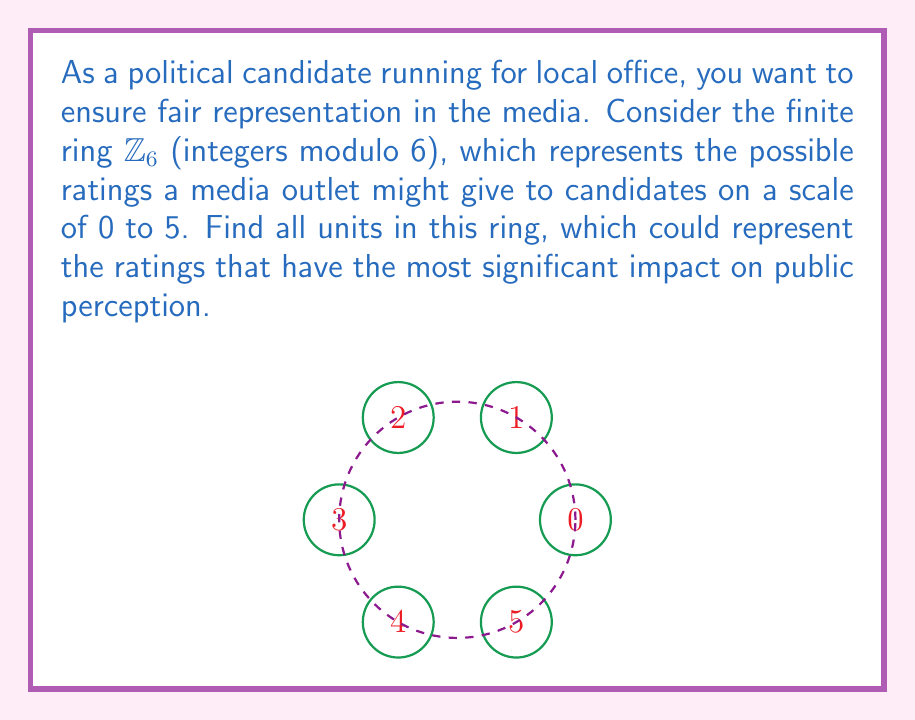What is the answer to this math problem? To find all units in the finite ring $\mathbb{Z}_6$, we need to identify elements that have multiplicative inverses. Let's approach this step-by-step:

1) In $\mathbb{Z}_6$, the elements are $\{0, 1, 2, 3, 4, 5\}$.

2) An element $a$ is a unit if there exists an element $b$ such that $ab \equiv 1 \pmod{6}$.

3) Let's check each element:

   For 0: $0 \cdot x \equiv 0 \pmod{6}$ for all $x$, so 0 is not a unit.
   
   For 1: $1 \cdot 1 \equiv 1 \pmod{6}$, so 1 is a unit.
   
   For 2: $2 \cdot x \equiv 1 \pmod{6}$ has no solution, so 2 is not a unit.
   
   For 3: $3 \cdot x \equiv 1 \pmod{6}$ has no solution, so 3 is not a unit.
   
   For 4: $4 \cdot x \equiv 1 \pmod{6}$ has no solution, so 4 is not a unit.
   
   For 5: $5 \cdot 5 \equiv 1 \pmod{6}$, so 5 is a unit.

4) We can verify: $5 \cdot 5 = 25 \equiv 1 \pmod{6}$

Therefore, the units in $\mathbb{Z}_6$ are 1 and 5.
Answer: $\{1, 5\}$ 